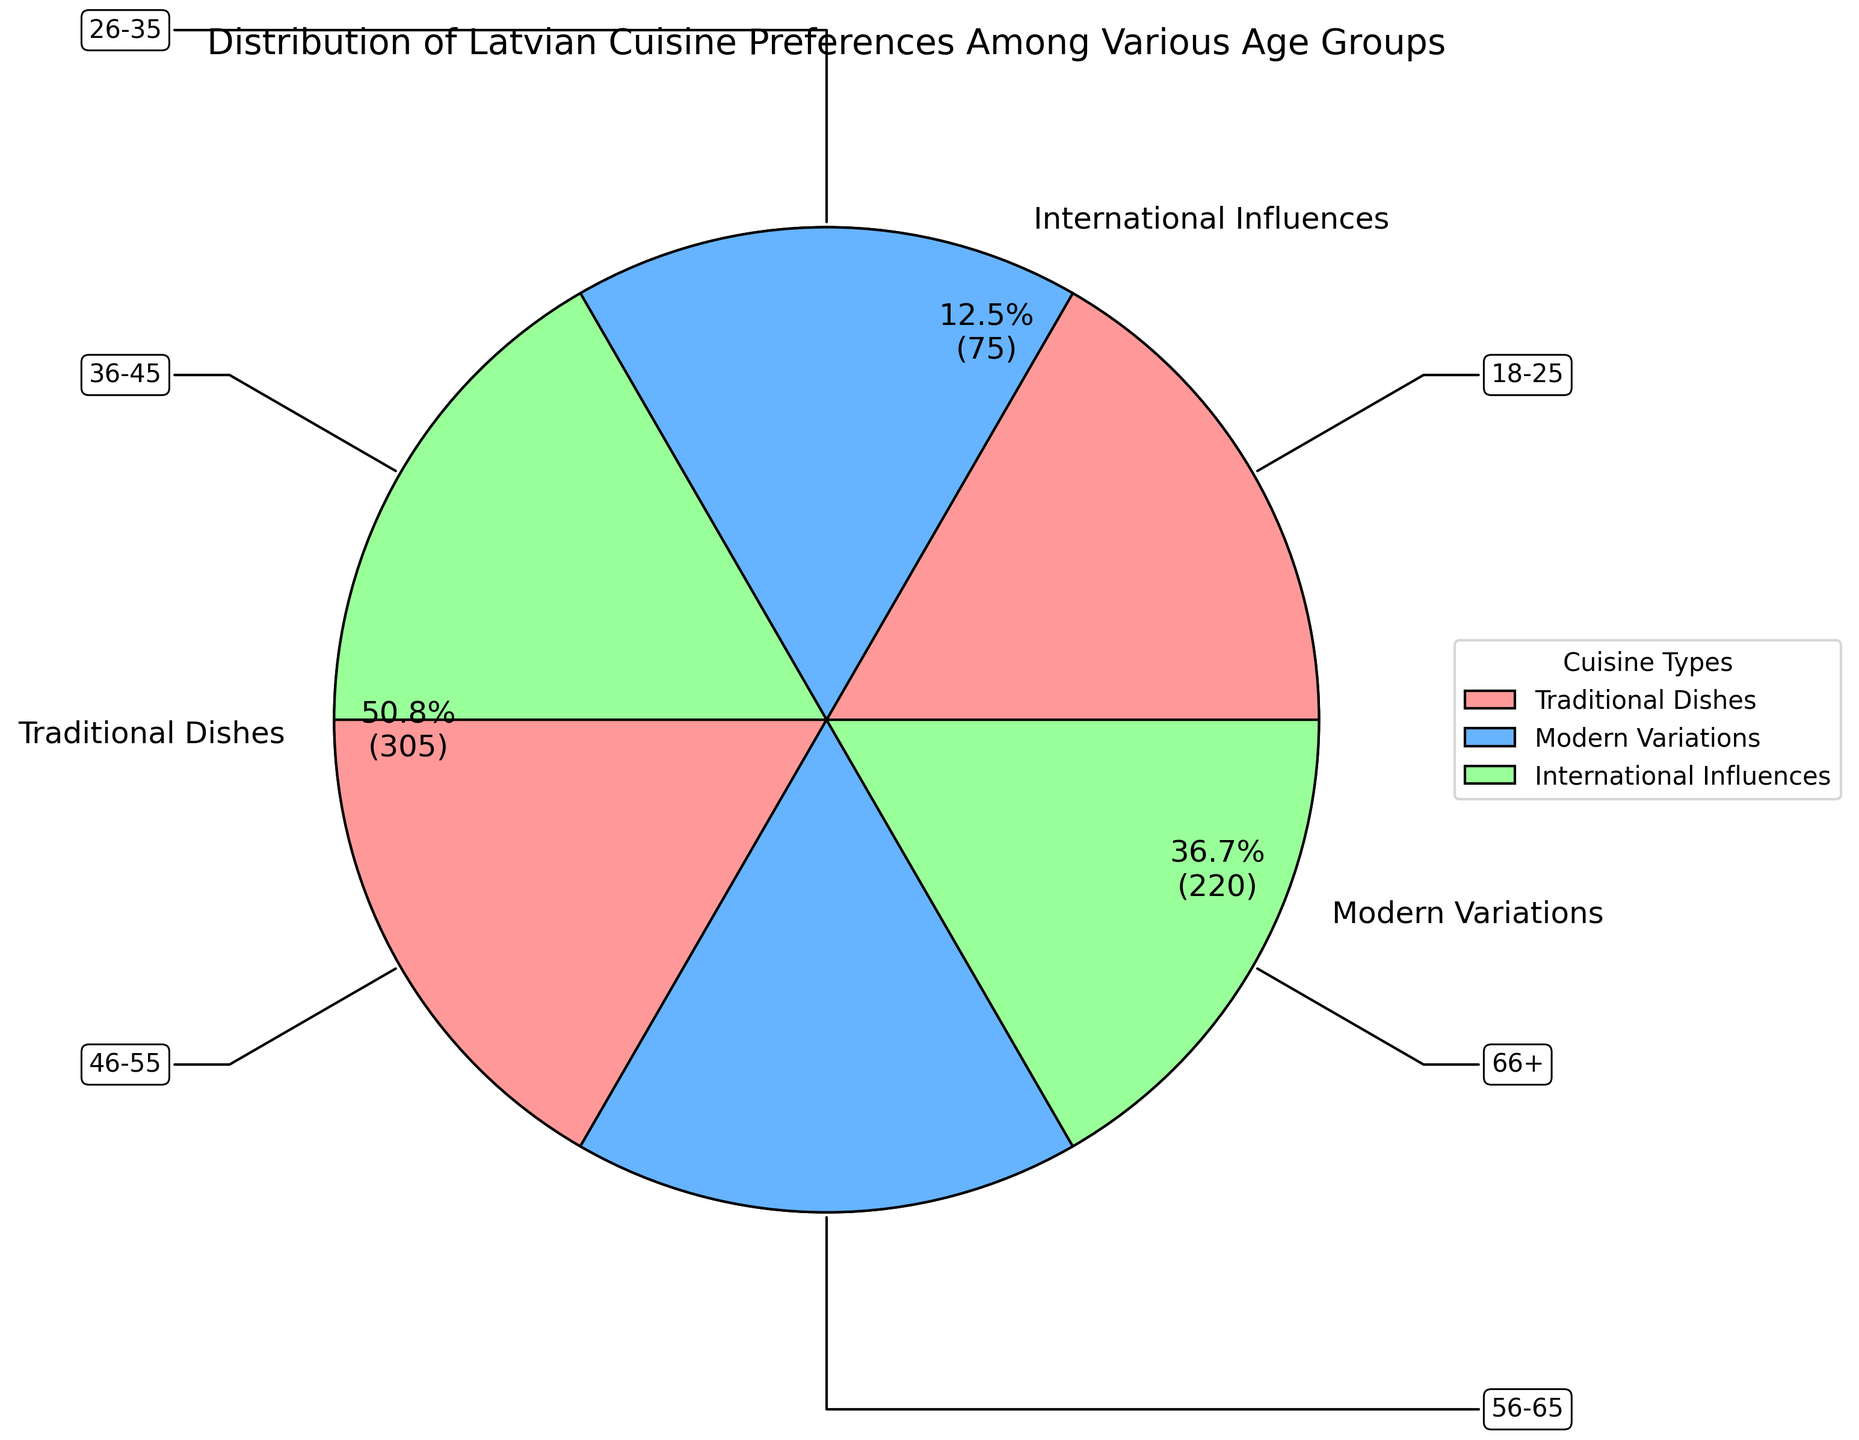Which age group has the highest preference for traditional dishes? By looking at the ring chart's segments, the age group with the largest segment for traditional dishes can be identified. The segment for age group 66+ is the largest for traditional dishes section.
Answer: 66+ How does the preference for international influences compare between the 18-25 and 66+ age groups? The ring chart shows the segments for international influences for both groups. Both age groups 18-25 and 66+ have a 10% preference for international influences.
Answer: Equal What is the total preference for modern variations from all age groups combined? Each age group's preference for modern variations is summed: 50 (18-25) + 45 (26-35) + 40 (36-45) + 35 (46-55) + 30 (56-65) + 20 (66+). This equals 220.
Answer: 220 Comparing the preferences for traditional dishes, which age group has a lower percentage: the 26-35 or the 56-65 group? Checking the chart, the traditional dishes preferences for the 26-35 group is 40% while the 56-65 group shows 60%. Thus, the 26-35 group has a lower percentage.
Answer: 26-35 What is the average preference for modern variations among all age groups? The sum of modern variations preferences is 220. There are six age groups, so the average is 220 / 6 = 36.67%.
Answer: 36.67% Which cuisine type has the smallest segment, and what percentage does it cover? Observing the pie wedges, the smallest segment is for international influences. The label indicates that it covers 11.83%.
Answer: International Influences, 11.83% Between the 36-45 and 46-55 age groups, which one has a higher combined preference for traditional dishes and international influences? For age group 36-45: 50% (traditional) + 10% (international) = 60%. For age group 46-55: 55% (traditional) + 10% (international) = 65%. The age group 46-55 has a higher combined preference.
Answer: 46-55 What is the difference in preference for traditional dishes between the youngest (18-25) and oldest (66+) age groups? The preference for traditional dishes of the 18-25 group is 30%, while it is 70% for the 66+ group. The difference is 70% - 30% = 40%.
Answer: 40% How does the preference for traditional dishes change from age group 18-25 to 66+? The preferences for traditional dishes in order are: 18-25 (30%), 26-35 (40%), 36-45 (50%), 46-55 (55%), 56-65 (60%), and 66+ (70%). There is a gradual increase in preference.
Answer: Gradual increase 